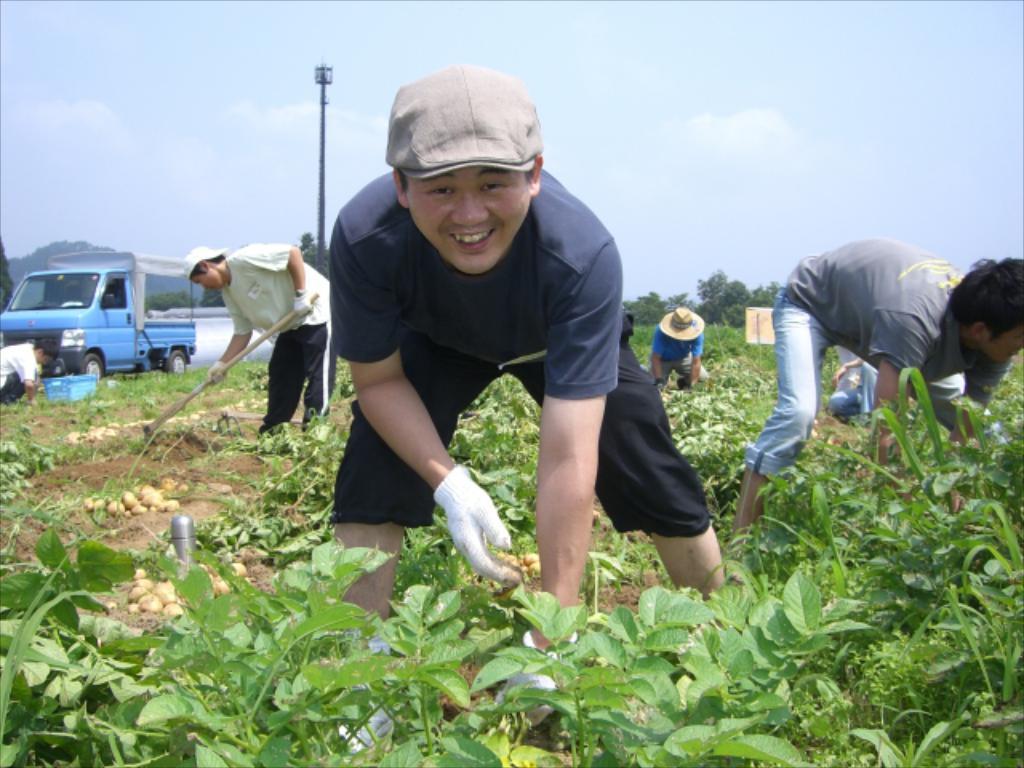Can you describe this image briefly? In this image we can see few persons, vegetables and plants. The person in the foreground is smiling. Behind the persons we can see a vehicle, pole, mountains and a group of trees. At the top we can see the sky. 